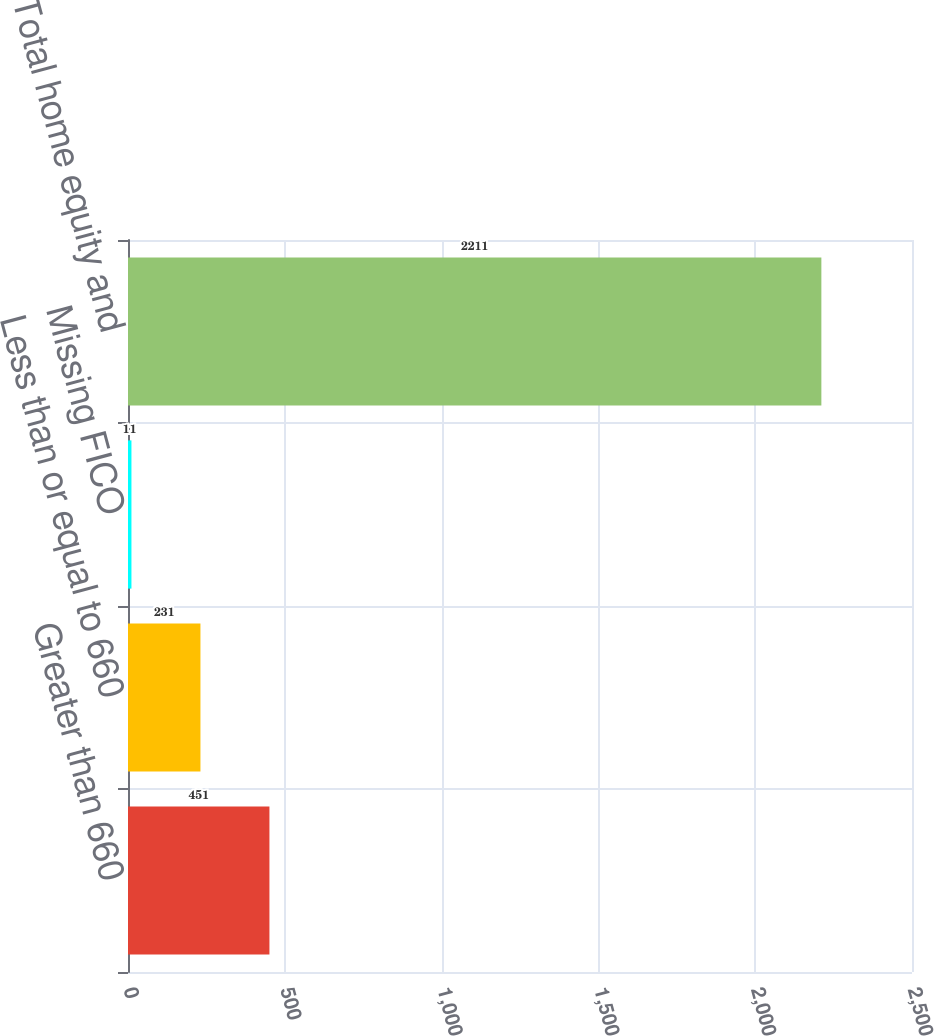<chart> <loc_0><loc_0><loc_500><loc_500><bar_chart><fcel>Greater than 660<fcel>Less than or equal to 660<fcel>Missing FICO<fcel>Total home equity and<nl><fcel>451<fcel>231<fcel>11<fcel>2211<nl></chart> 